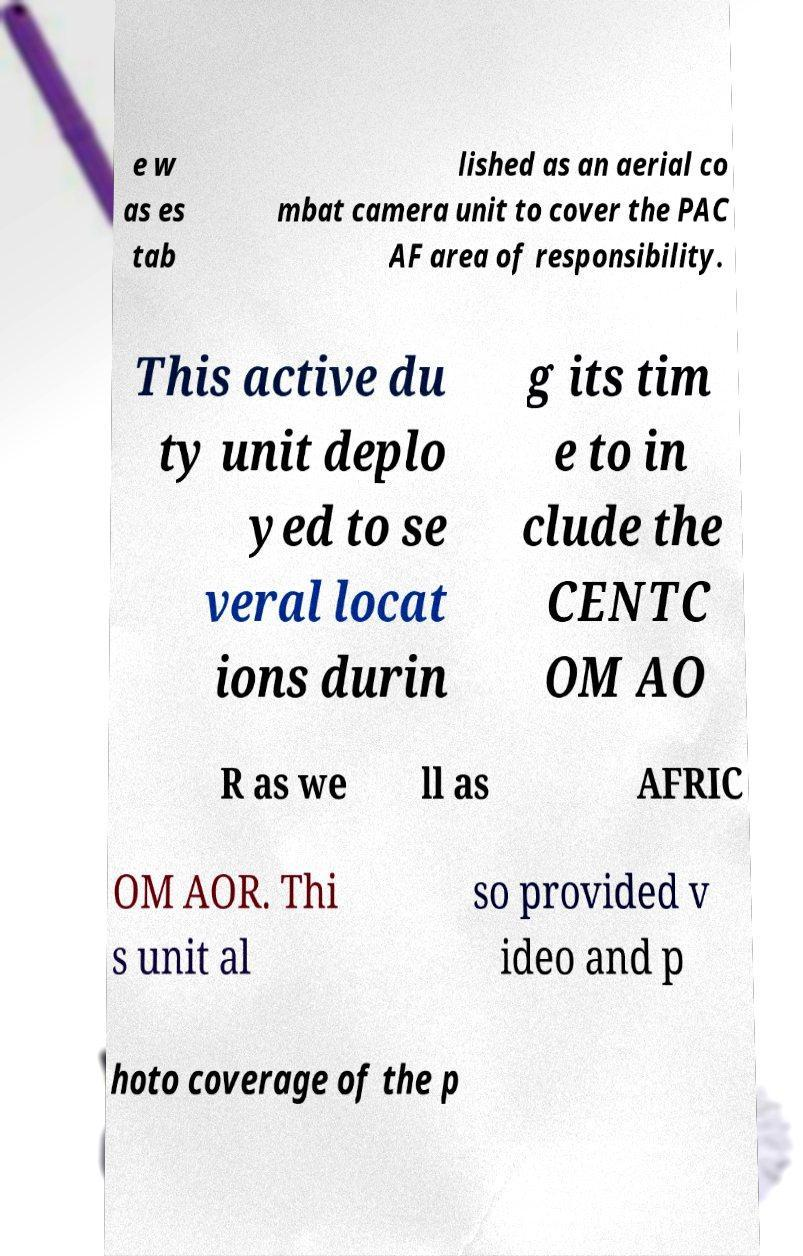Can you read and provide the text displayed in the image?This photo seems to have some interesting text. Can you extract and type it out for me? e w as es tab lished as an aerial co mbat camera unit to cover the PAC AF area of responsibility. This active du ty unit deplo yed to se veral locat ions durin g its tim e to in clude the CENTC OM AO R as we ll as AFRIC OM AOR. Thi s unit al so provided v ideo and p hoto coverage of the p 